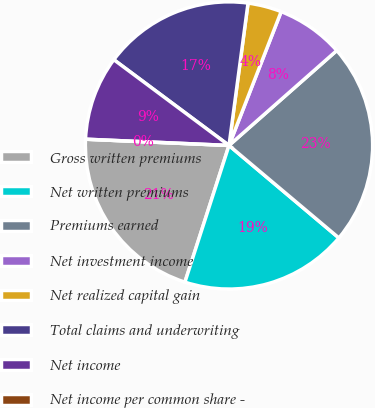<chart> <loc_0><loc_0><loc_500><loc_500><pie_chart><fcel>Gross written premiums<fcel>Net written premiums<fcel>Premiums earned<fcel>Net investment income<fcel>Net realized capital gain<fcel>Total claims and underwriting<fcel>Net income<fcel>Net income per common share -<nl><fcel>20.73%<fcel>18.83%<fcel>22.63%<fcel>7.59%<fcel>3.8%<fcel>16.93%<fcel>9.49%<fcel>0.0%<nl></chart> 